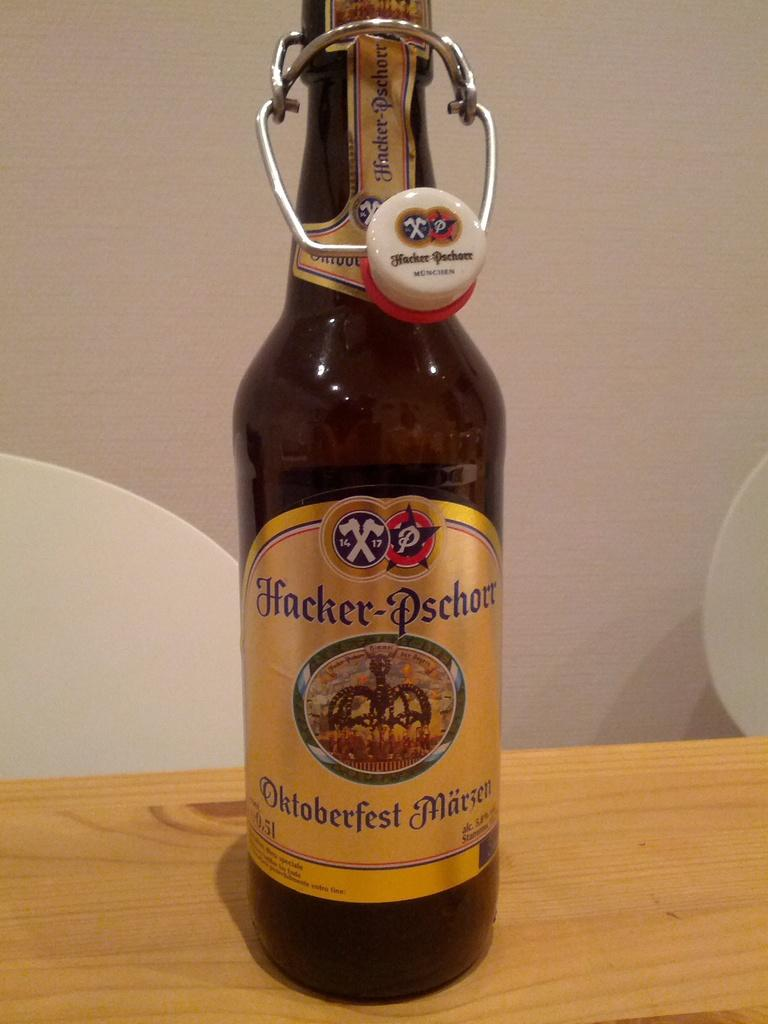<image>
Create a compact narrative representing the image presented. A bottle of beer with a gold label that reads Hacker-Pschort 